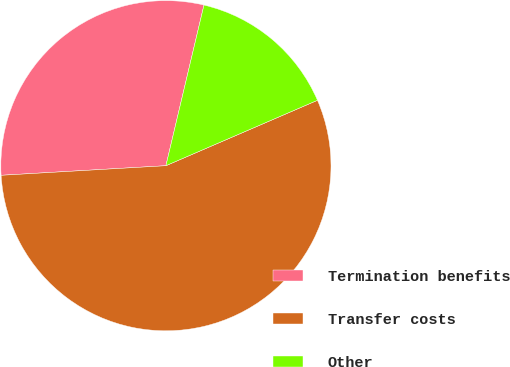Convert chart. <chart><loc_0><loc_0><loc_500><loc_500><pie_chart><fcel>Termination benefits<fcel>Transfer costs<fcel>Other<nl><fcel>29.63%<fcel>55.56%<fcel>14.81%<nl></chart> 